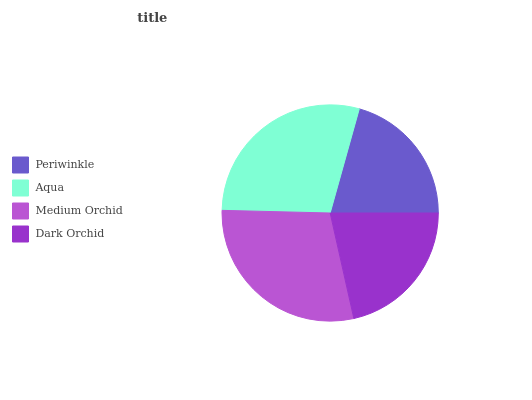Is Periwinkle the minimum?
Answer yes or no. Yes. Is Aqua the maximum?
Answer yes or no. Yes. Is Medium Orchid the minimum?
Answer yes or no. No. Is Medium Orchid the maximum?
Answer yes or no. No. Is Aqua greater than Medium Orchid?
Answer yes or no. Yes. Is Medium Orchid less than Aqua?
Answer yes or no. Yes. Is Medium Orchid greater than Aqua?
Answer yes or no. No. Is Aqua less than Medium Orchid?
Answer yes or no. No. Is Medium Orchid the high median?
Answer yes or no. Yes. Is Dark Orchid the low median?
Answer yes or no. Yes. Is Dark Orchid the high median?
Answer yes or no. No. Is Aqua the low median?
Answer yes or no. No. 